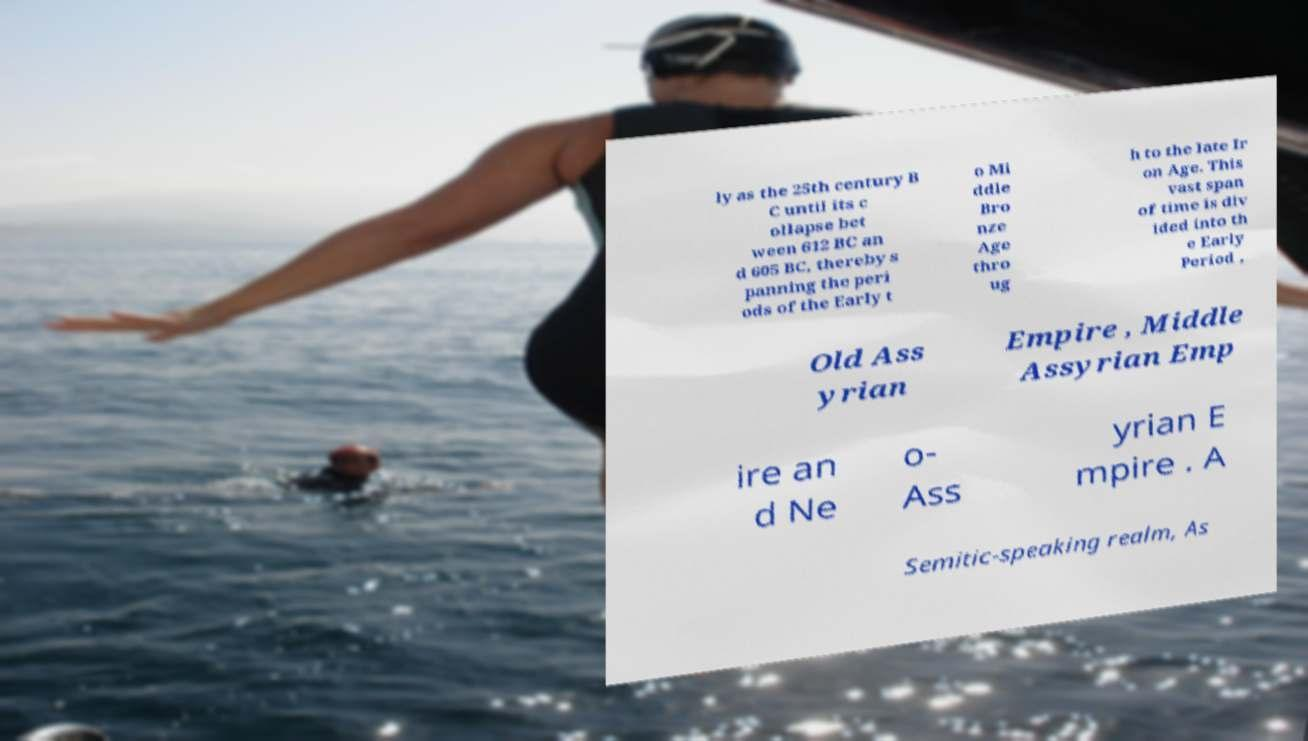There's text embedded in this image that I need extracted. Can you transcribe it verbatim? ly as the 25th century B C until its c ollapse bet ween 612 BC an d 605 BC, thereby s panning the peri ods of the Early t o Mi ddle Bro nze Age thro ug h to the late Ir on Age. This vast span of time is div ided into th e Early Period , Old Ass yrian Empire , Middle Assyrian Emp ire an d Ne o- Ass yrian E mpire . A Semitic-speaking realm, As 